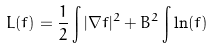Convert formula to latex. <formula><loc_0><loc_0><loc_500><loc_500>L ( f ) = \frac { 1 } { 2 } \int | \nabla f | ^ { 2 } + B ^ { 2 } \int \ln ( f )</formula> 